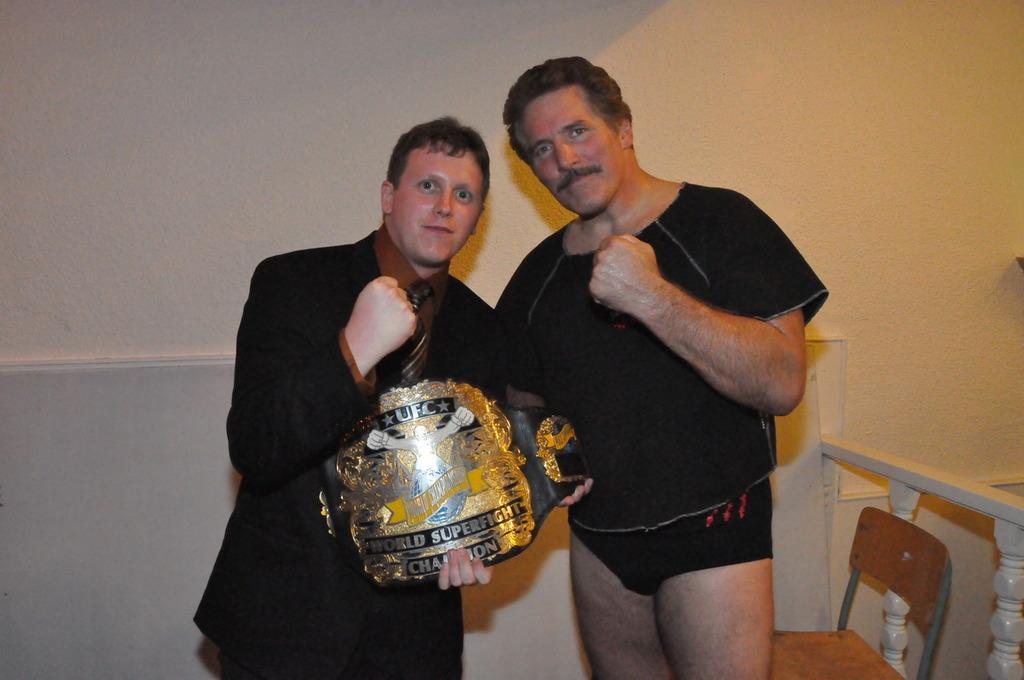How many people are in the image? There are two people in the image. What is one person wearing? One person is wearing a suit. What is the person in the suit holding? The person in the suit is holding a memento. Can you describe any furniture in the image? Yes, there is a chair is present in the image. What type of barrier can be seen in the image? There is a fencing in the image. How many jellyfish can be seen swimming in the image? There are no jellyfish present in the image. What type of order is being followed by the twig in the image? There is no twig present in the image. 